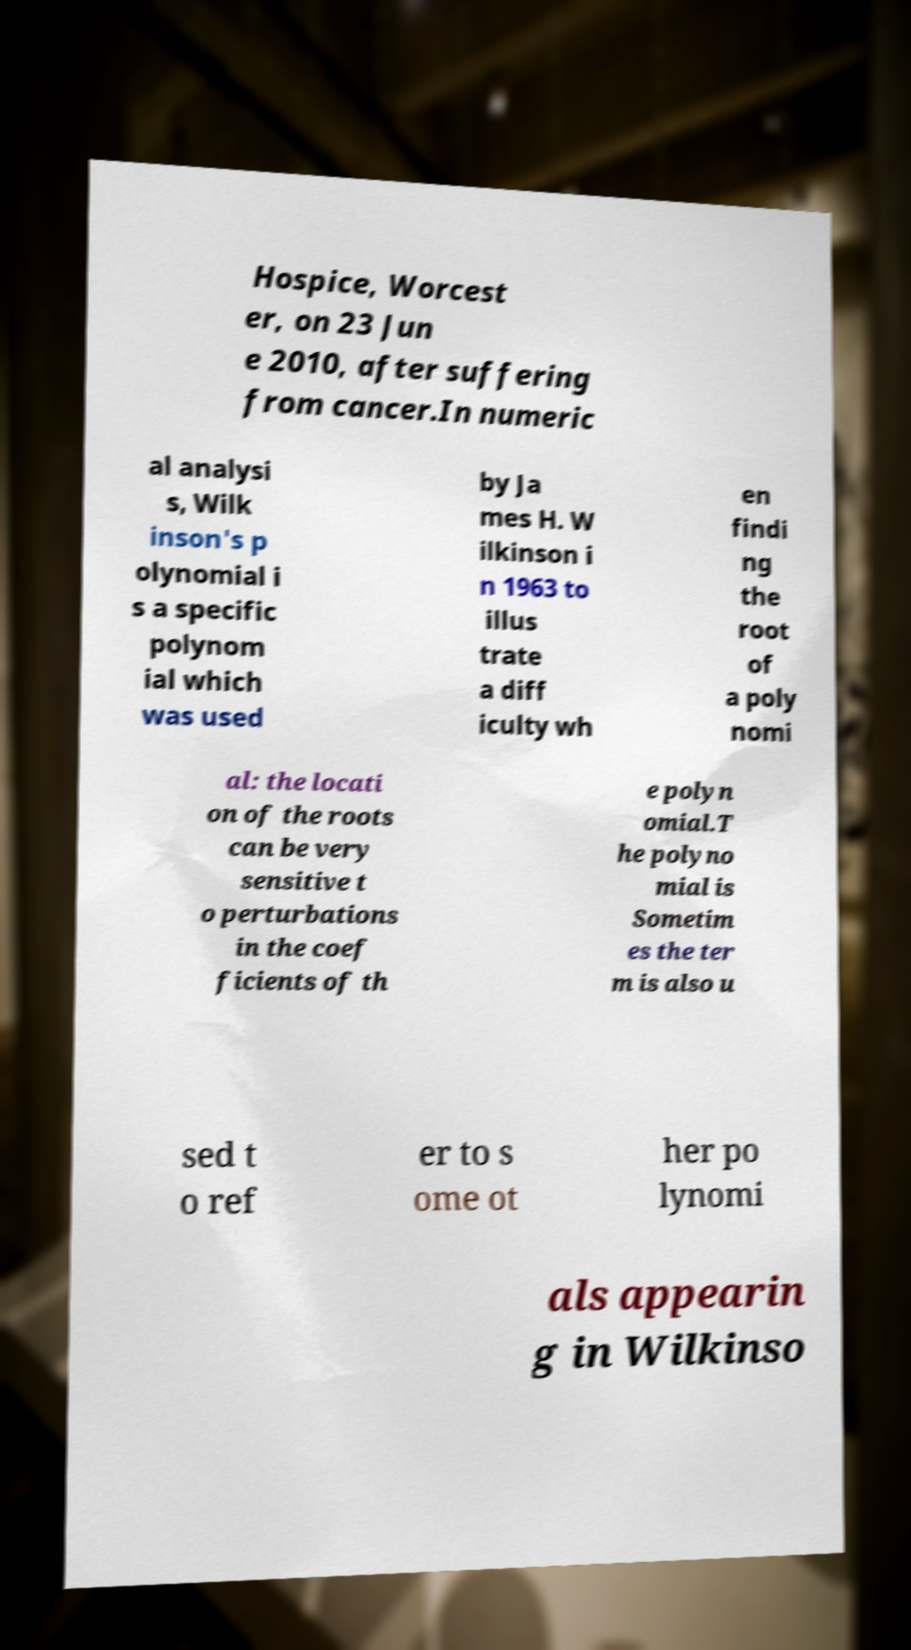Can you accurately transcribe the text from the provided image for me? Hospice, Worcest er, on 23 Jun e 2010, after suffering from cancer.In numeric al analysi s, Wilk inson's p olynomial i s a specific polynom ial which was used by Ja mes H. W ilkinson i n 1963 to illus trate a diff iculty wh en findi ng the root of a poly nomi al: the locati on of the roots can be very sensitive t o perturbations in the coef ficients of th e polyn omial.T he polyno mial is Sometim es the ter m is also u sed t o ref er to s ome ot her po lynomi als appearin g in Wilkinso 